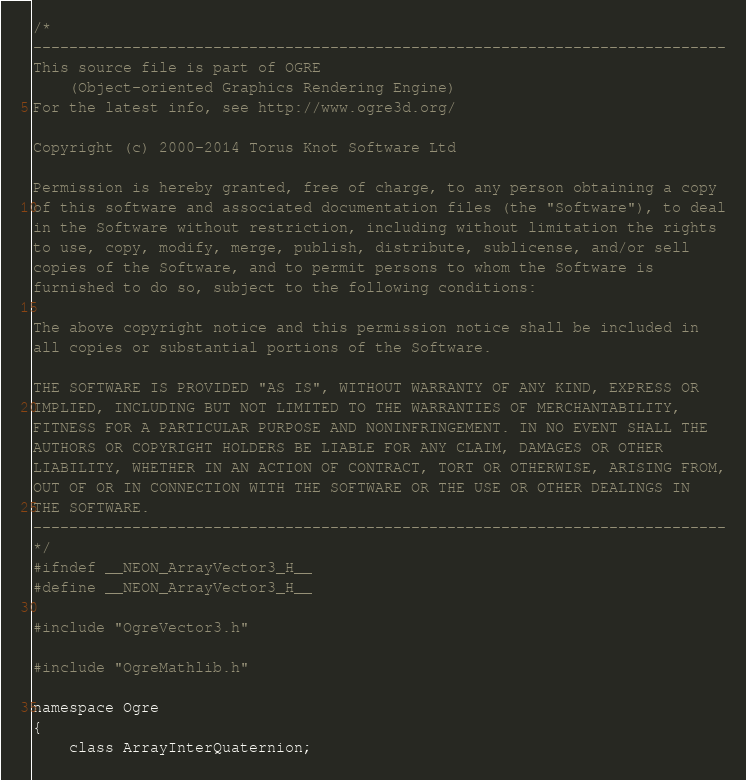Convert code to text. <code><loc_0><loc_0><loc_500><loc_500><_C_>/*
-----------------------------------------------------------------------------
This source file is part of OGRE
    (Object-oriented Graphics Rendering Engine)
For the latest info, see http://www.ogre3d.org/

Copyright (c) 2000-2014 Torus Knot Software Ltd

Permission is hereby granted, free of charge, to any person obtaining a copy
of this software and associated documentation files (the "Software"), to deal
in the Software without restriction, including without limitation the rights
to use, copy, modify, merge, publish, distribute, sublicense, and/or sell
copies of the Software, and to permit persons to whom the Software is
furnished to do so, subject to the following conditions:

The above copyright notice and this permission notice shall be included in
all copies or substantial portions of the Software.

THE SOFTWARE IS PROVIDED "AS IS", WITHOUT WARRANTY OF ANY KIND, EXPRESS OR
IMPLIED, INCLUDING BUT NOT LIMITED TO THE WARRANTIES OF MERCHANTABILITY,
FITNESS FOR A PARTICULAR PURPOSE AND NONINFRINGEMENT. IN NO EVENT SHALL THE
AUTHORS OR COPYRIGHT HOLDERS BE LIABLE FOR ANY CLAIM, DAMAGES OR OTHER
LIABILITY, WHETHER IN AN ACTION OF CONTRACT, TORT OR OTHERWISE, ARISING FROM,
OUT OF OR IN CONNECTION WITH THE SOFTWARE OR THE USE OR OTHER DEALINGS IN
THE SOFTWARE.
-----------------------------------------------------------------------------
*/
#ifndef __NEON_ArrayVector3_H__
#define __NEON_ArrayVector3_H__

#include "OgreVector3.h"

#include "OgreMathlib.h"

namespace Ogre
{
    class ArrayInterQuaternion;
</code> 